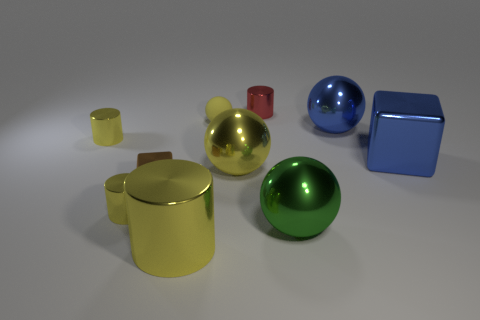Subtract all brown spheres. How many yellow cylinders are left? 3 Subtract all small balls. How many balls are left? 3 Subtract 1 cylinders. How many cylinders are left? 3 Subtract all gray spheres. Subtract all red cubes. How many spheres are left? 4 Subtract all blocks. How many objects are left? 8 Subtract all big gray rubber cylinders. Subtract all brown shiny things. How many objects are left? 9 Add 2 small matte spheres. How many small matte spheres are left? 3 Add 1 large yellow blocks. How many large yellow blocks exist? 1 Subtract 0 green cylinders. How many objects are left? 10 